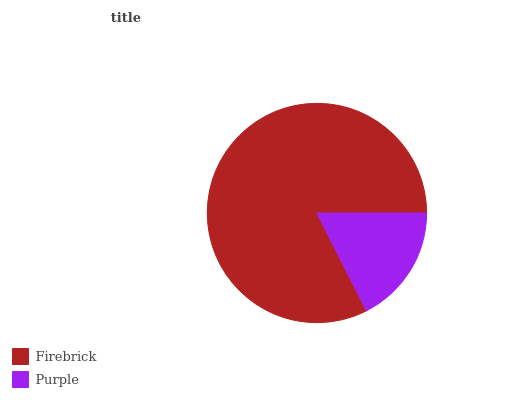Is Purple the minimum?
Answer yes or no. Yes. Is Firebrick the maximum?
Answer yes or no. Yes. Is Purple the maximum?
Answer yes or no. No. Is Firebrick greater than Purple?
Answer yes or no. Yes. Is Purple less than Firebrick?
Answer yes or no. Yes. Is Purple greater than Firebrick?
Answer yes or no. No. Is Firebrick less than Purple?
Answer yes or no. No. Is Firebrick the high median?
Answer yes or no. Yes. Is Purple the low median?
Answer yes or no. Yes. Is Purple the high median?
Answer yes or no. No. Is Firebrick the low median?
Answer yes or no. No. 